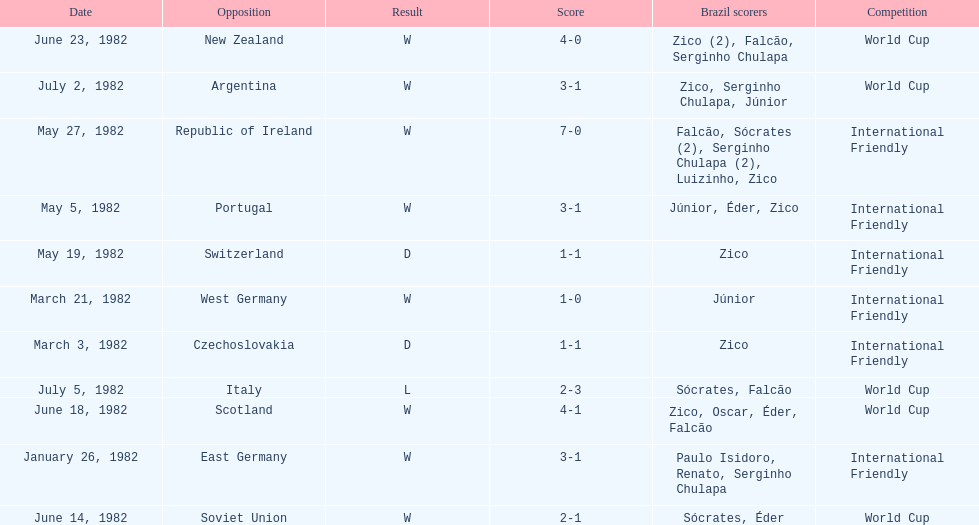What date is at the top of the list? January 26, 1982. 